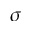Convert formula to latex. <formula><loc_0><loc_0><loc_500><loc_500>\sigma</formula> 